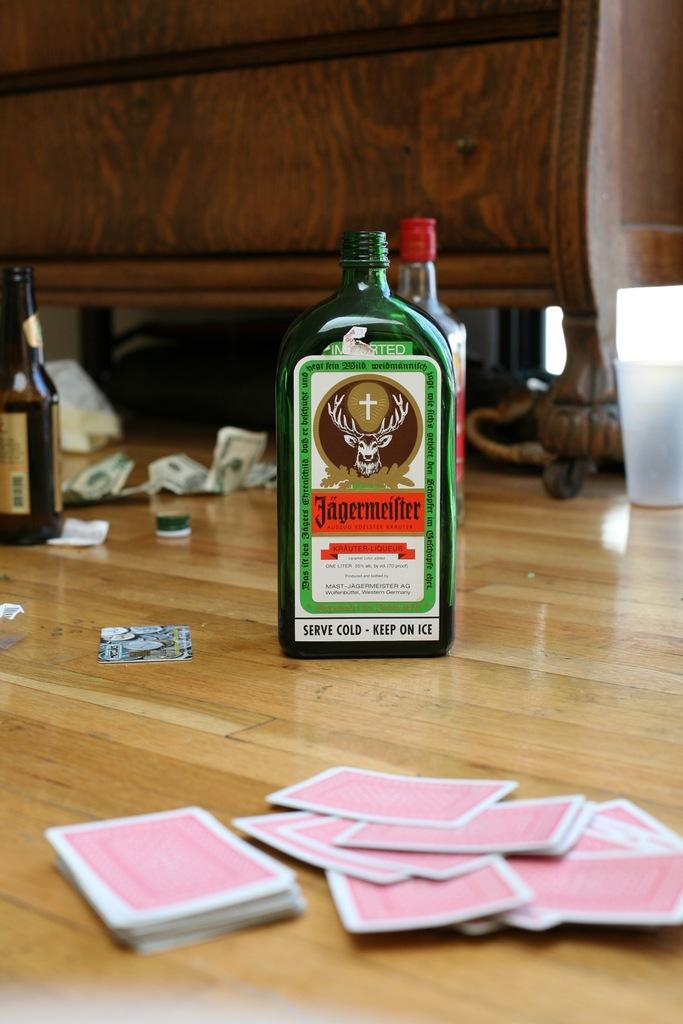Provide a one-sentence caption for the provided image. Several bottles including a green bottle of Jaegermeister on a wooden floor  next to some red playing cards. 